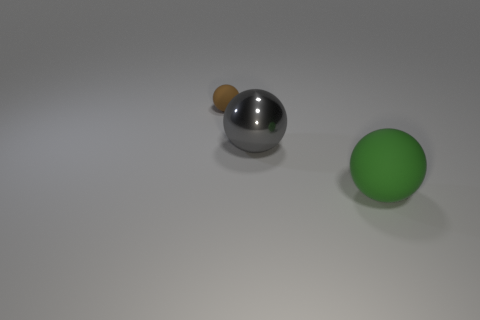How many red objects are spheres or big objects?
Ensure brevity in your answer.  0. There is another ball that is the same size as the gray metal ball; what is its color?
Offer a very short reply. Green. There is a tiny brown matte object; does it have the same shape as the large thing to the left of the large rubber thing?
Offer a terse response. Yes. What is the material of the ball that is behind the large ball that is left of the rubber sphere on the right side of the brown object?
Your response must be concise. Rubber. How many large objects are either brown objects or green spheres?
Provide a succinct answer. 1. What number of other things are there of the same size as the green ball?
Your answer should be compact. 1. Does the large object left of the large green rubber thing have the same shape as the tiny rubber object?
Your response must be concise. Yes. What is the color of the metal object that is the same shape as the brown matte thing?
Your answer should be very brief. Gray. Is there anything else that is the same shape as the green matte object?
Your answer should be very brief. Yes. Are there the same number of gray objects that are to the left of the tiny matte sphere and tiny gray rubber cubes?
Your answer should be very brief. Yes. 